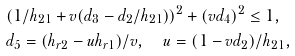Convert formula to latex. <formula><loc_0><loc_0><loc_500><loc_500>& ( 1 / h _ { 2 1 } + v ( d _ { 3 } - d _ { 2 } / h _ { 2 1 } ) ) ^ { 2 } + ( v d _ { 4 } ) ^ { 2 } \leq 1 , \\ & d _ { 5 } = ( h _ { r 2 } - u h _ { r 1 } ) / v , \quad u = ( 1 - v d _ { 2 } ) / h _ { 2 1 } ,</formula> 